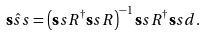Convert formula to latex. <formula><loc_0><loc_0><loc_500><loc_500>\hat { \mathbf s s s } = \left ( { \mathbf s s R } ^ { \dagger } { \mathbf s s R } \right ) ^ { - 1 } { \mathbf s s R } ^ { \dagger } { \mathbf s s d } .</formula> 